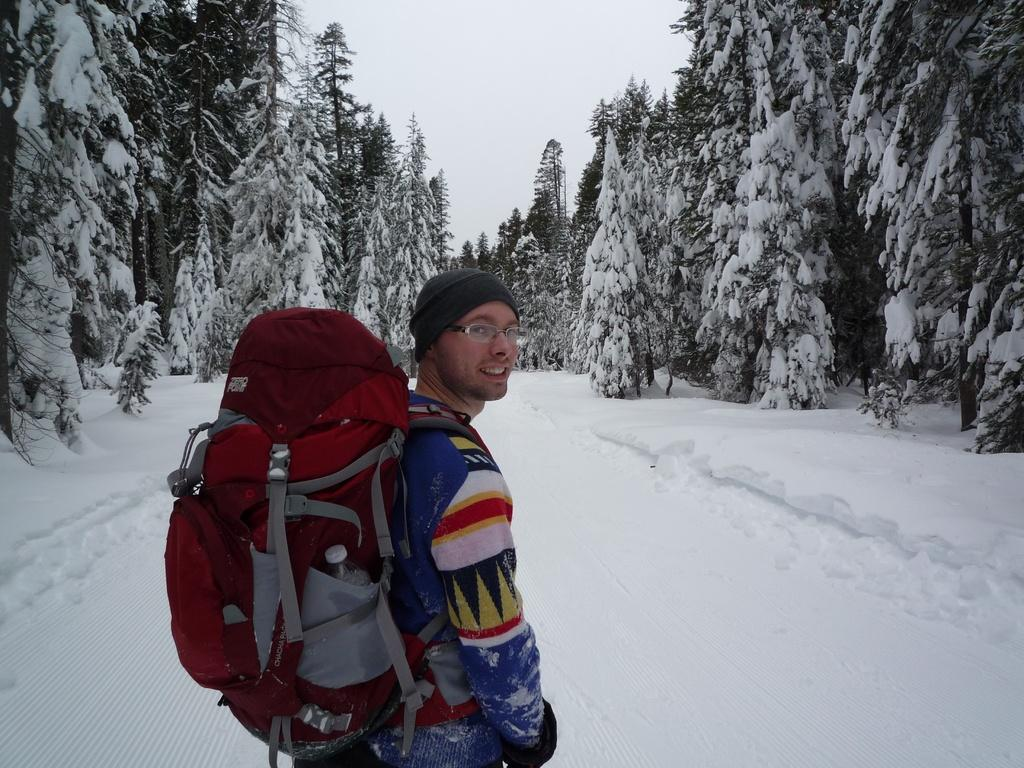Who is present in the image? There is a man in the image. What is the man carrying in the image? The man is standing with a backpack. What is the condition of the environment in the image? The area is snowy, and trees covered with snow are visible on both sides of the image. What is the condition of the sky in the image? The sky is clear in the image. Can you see any cobwebs hanging from the trees in the image? There is no mention of cobwebs in the image, and they are not visible in the provided facts. What sign is the man holding in the image? There is no sign present in the image; the man is simply standing with a backpack. 